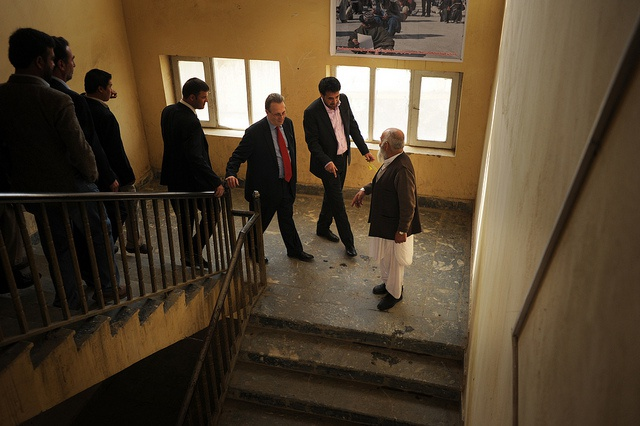Describe the objects in this image and their specific colors. I can see people in olive, black, and gray tones, people in olive, black, maroon, and gray tones, people in olive, black, gray, maroon, and tan tones, people in olive, black, maroon, and tan tones, and people in olive, black, maroon, and brown tones in this image. 